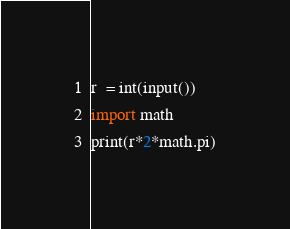<code> <loc_0><loc_0><loc_500><loc_500><_Python_>r  = int(input())
import math
print(r*2*math.pi)</code> 